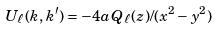Convert formula to latex. <formula><loc_0><loc_0><loc_500><loc_500>U _ { \ell } ( k , k ^ { \prime } ) = - 4 a \, Q _ { \ell } ( z ) / ( x ^ { 2 } - y ^ { 2 } )</formula> 